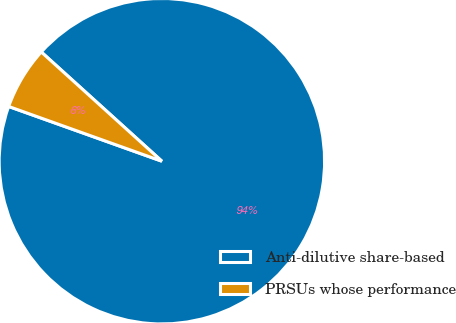Convert chart to OTSL. <chart><loc_0><loc_0><loc_500><loc_500><pie_chart><fcel>Anti-dilutive share-based<fcel>PRSUs whose performance<nl><fcel>93.75%<fcel>6.25%<nl></chart> 